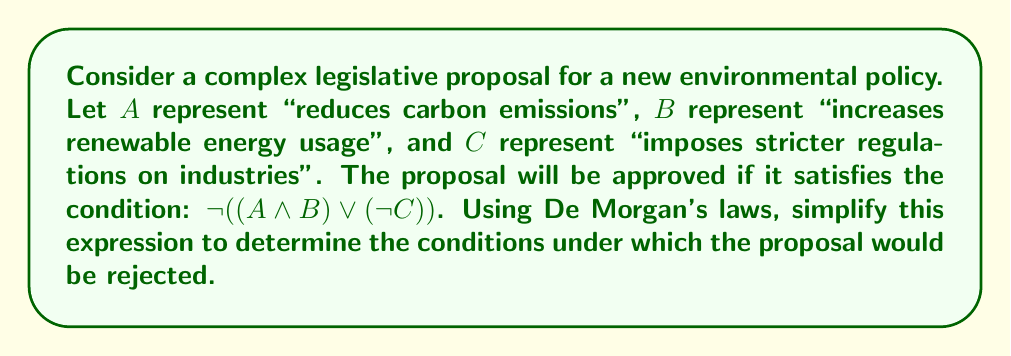Give your solution to this math problem. To simplify the expression and determine when the proposal would be rejected, we need to apply De Morgan's laws to the negation of the given condition.

Step 1: Apply the first De Morgan's law to the outer negation:
$\neg((A \land B) \lor (\neg C))$ = $(\neg(A \land B)) \land (\neg(\neg C))$

Step 2: Apply De Morgan's law to $\neg(A \land B)$:
$(\neg A \lor \neg B) \land (\neg(\neg C))$

Step 3: Simplify the double negation $\neg(\neg C)$:
$(\neg A \lor \neg B) \land C$

Therefore, the proposal would be rejected if:
- It does not reduce carbon emissions OR does not increase renewable energy usage, AND
- It imposes stricter regulations on industries

This simplified form helps policymakers quickly understand the conditions under which the proposal would fail, which is crucial for assessing and refining legislative proposals in civil service roles.
Answer: $(\neg A \lor \neg B) \land C$ 